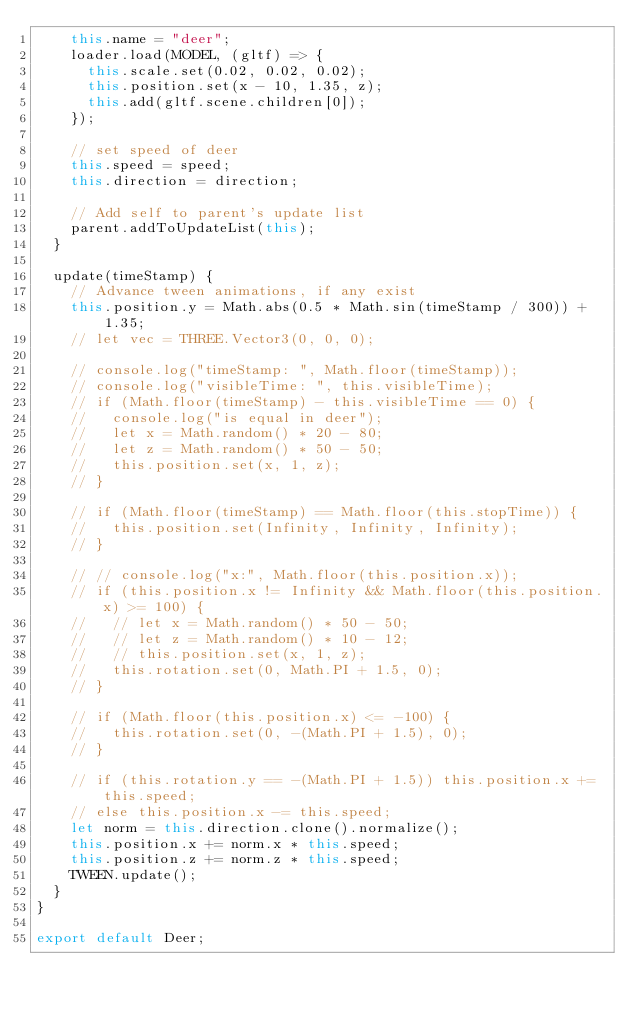<code> <loc_0><loc_0><loc_500><loc_500><_JavaScript_>    this.name = "deer";
    loader.load(MODEL, (gltf) => {
      this.scale.set(0.02, 0.02, 0.02);
      this.position.set(x - 10, 1.35, z);
      this.add(gltf.scene.children[0]);
    });

    // set speed of deer
    this.speed = speed;
    this.direction = direction;

    // Add self to parent's update list
    parent.addToUpdateList(this);
  }

  update(timeStamp) {
    // Advance tween animations, if any exist
    this.position.y = Math.abs(0.5 * Math.sin(timeStamp / 300)) + 1.35;
    // let vec = THREE.Vector3(0, 0, 0);

    // console.log("timeStamp: ", Math.floor(timeStamp));
    // console.log("visibleTime: ", this.visibleTime);
    // if (Math.floor(timeStamp) - this.visibleTime == 0) {
    //   console.log("is equal in deer");
    //   let x = Math.random() * 20 - 80;
    //   let z = Math.random() * 50 - 50;
    //   this.position.set(x, 1, z);
    // }

    // if (Math.floor(timeStamp) == Math.floor(this.stopTime)) {
    //   this.position.set(Infinity, Infinity, Infinity);
    // }

    // // console.log("x:", Math.floor(this.position.x));
    // if (this.position.x != Infinity && Math.floor(this.position.x) >= 100) {
    //   // let x = Math.random() * 50 - 50;
    //   // let z = Math.random() * 10 - 12;
    //   // this.position.set(x, 1, z);
    //   this.rotation.set(0, Math.PI + 1.5, 0);
    // }

    // if (Math.floor(this.position.x) <= -100) {
    //   this.rotation.set(0, -(Math.PI + 1.5), 0);
    // }

    // if (this.rotation.y == -(Math.PI + 1.5)) this.position.x += this.speed;
    // else this.position.x -= this.speed;
    let norm = this.direction.clone().normalize();
    this.position.x += norm.x * this.speed;
    this.position.z += norm.z * this.speed;
    TWEEN.update();
  }
}

export default Deer;
</code> 